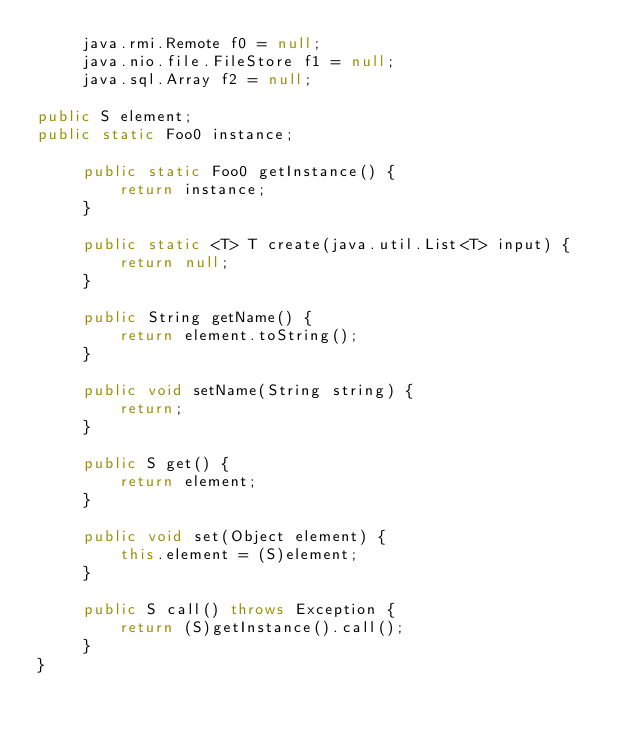<code> <loc_0><loc_0><loc_500><loc_500><_Java_>	 java.rmi.Remote f0 = null;
	 java.nio.file.FileStore f1 = null;
	 java.sql.Array f2 = null;

public S element;
public static Foo0 instance;

	 public static Foo0 getInstance() {
	 	 return instance;
	 }

	 public static <T> T create(java.util.List<T> input) {
	 	 return null;
	 }

	 public String getName() {
	 	 return element.toString();
	 }

	 public void setName(String string) {
	 	 return;
	 }

	 public S get() {
	 	 return element;
	 }

	 public void set(Object element) {
	 	 this.element = (S)element;
	 }

	 public S call() throws Exception {
	 	 return (S)getInstance().call();
	 }
}
</code> 